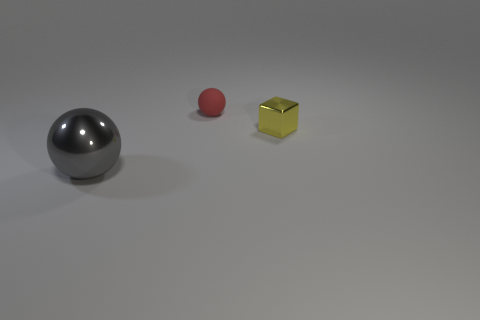Subtract all gray cubes. Subtract all cyan spheres. How many cubes are left? 1 Add 1 tiny green matte spheres. How many objects exist? 4 Subtract all cubes. How many objects are left? 2 Add 2 gray objects. How many gray objects are left? 3 Add 1 yellow objects. How many yellow objects exist? 2 Subtract 0 red cylinders. How many objects are left? 3 Subtract all big red metal cylinders. Subtract all big gray spheres. How many objects are left? 2 